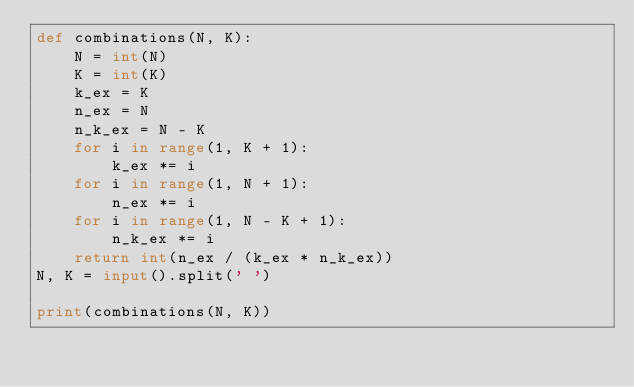<code> <loc_0><loc_0><loc_500><loc_500><_Python_>def combinations(N, K):
    N = int(N)
    K = int(K)
    k_ex = K
    n_ex = N
    n_k_ex = N - K
    for i in range(1, K + 1):
        k_ex *= i
    for i in range(1, N + 1):
        n_ex *= i
    for i in range(1, N - K + 1):
        n_k_ex *= i
    return int(n_ex / (k_ex * n_k_ex))
N, K = input().split(' ')

print(combinations(N, K))</code> 